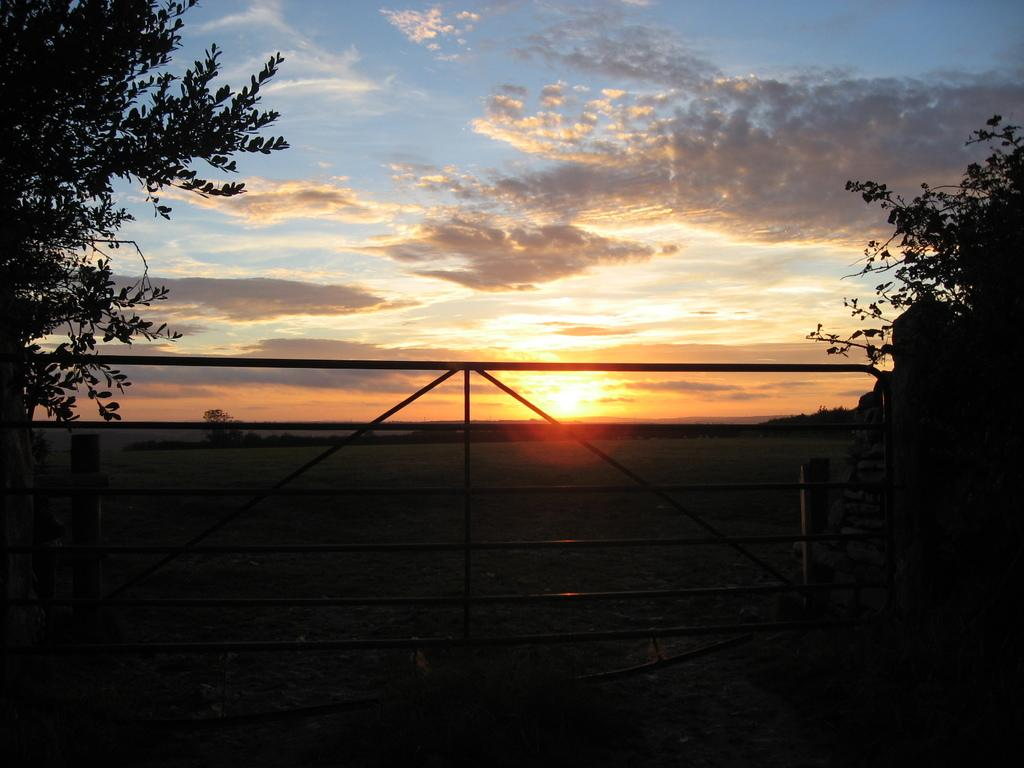What structure can be seen in the image? There is a gate in the image. What is located behind the gate? There are poles and trees behind the gate. What is visible in the sky in the image? The sun is visible in the sky in the image. Can you see a cup hanging from the tree in the image? There is no cup hanging from the tree in the image. Is there a crow perched on the gate in the image? There is no crow present in the image. 